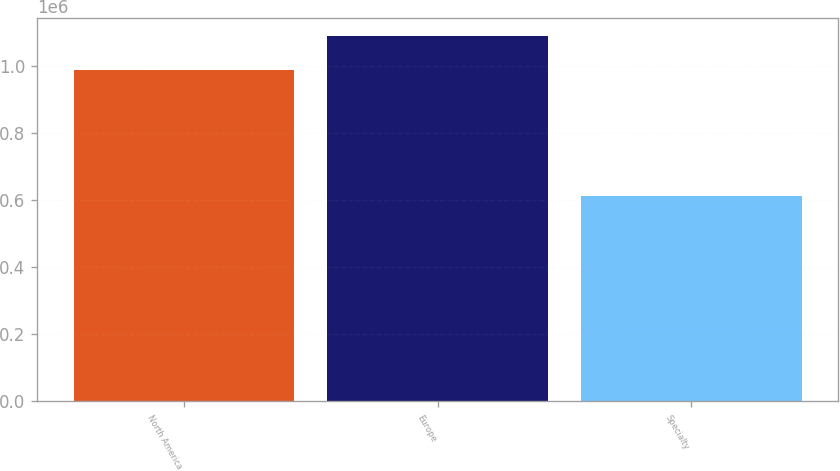<chart> <loc_0><loc_0><loc_500><loc_500><bar_chart><fcel>North America<fcel>Europe<fcel>Specialty<nl><fcel>985300<fcel>1.08702e+06<fcel>612970<nl></chart> 